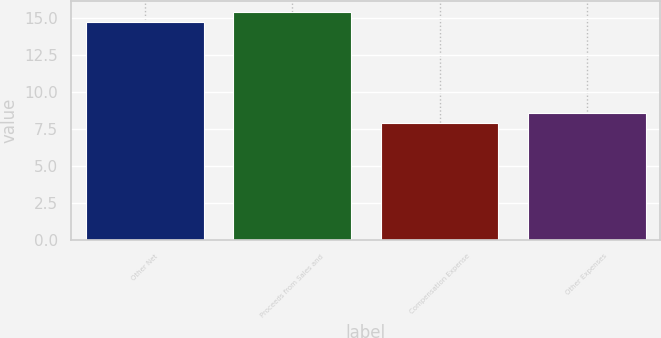<chart> <loc_0><loc_0><loc_500><loc_500><bar_chart><fcel>Other Net<fcel>Proceeds from Sales and<fcel>Compensation Expense<fcel>Other Expenses<nl><fcel>14.7<fcel>15.38<fcel>7.9<fcel>8.58<nl></chart> 